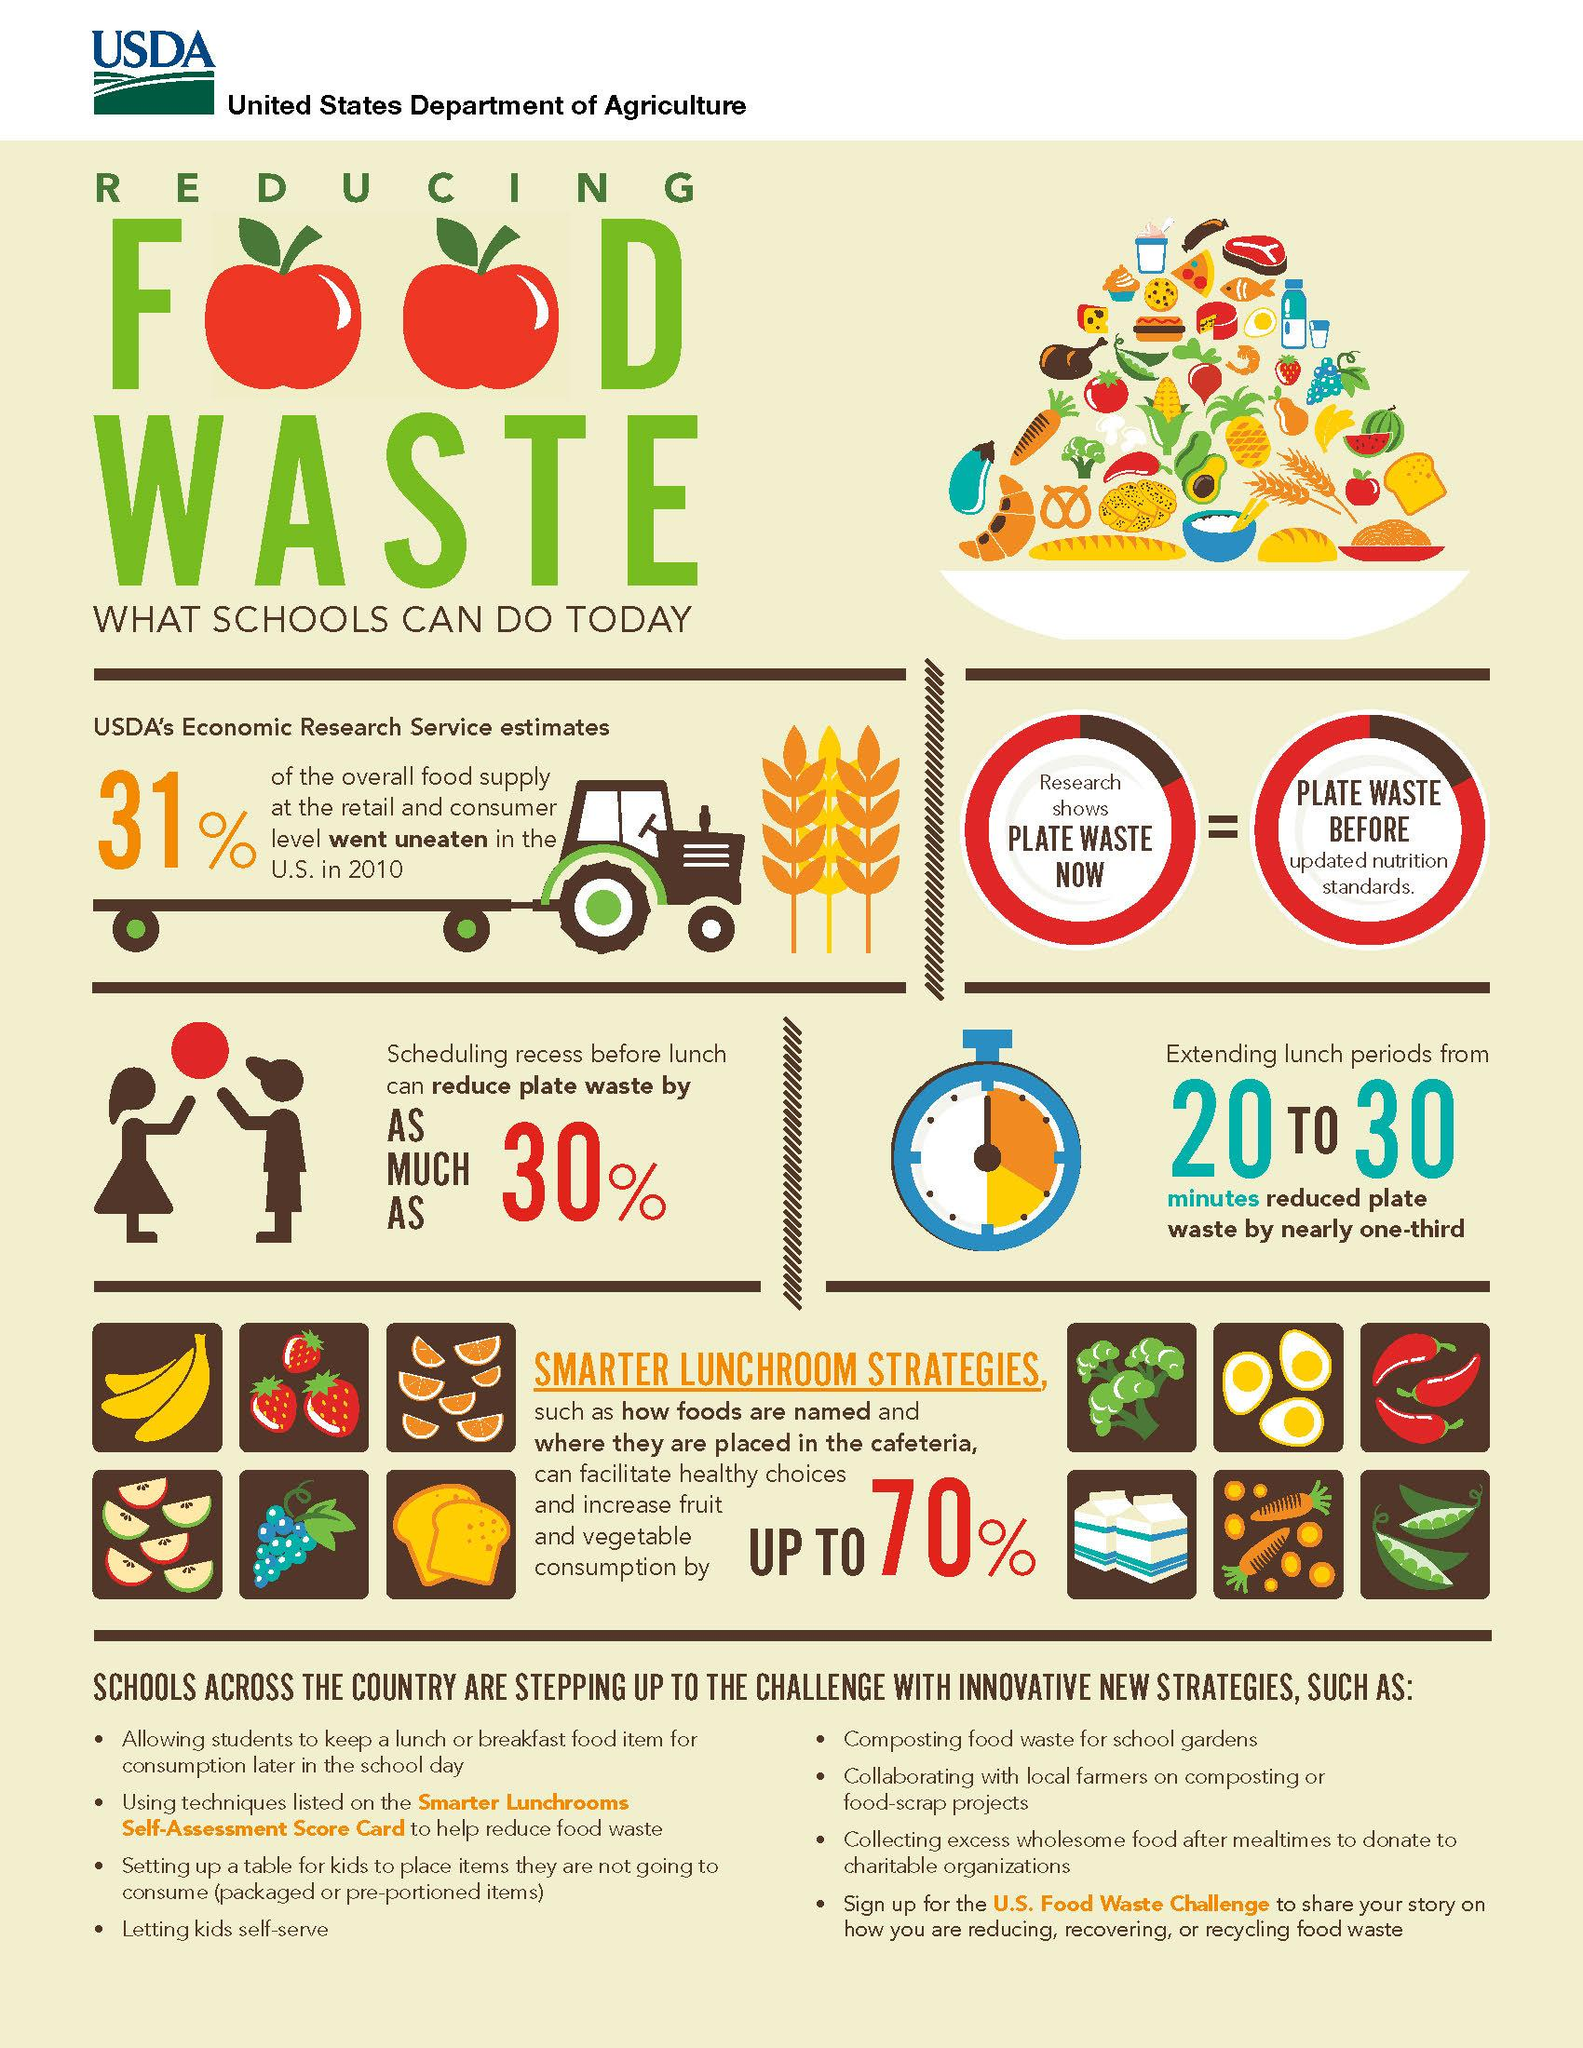Mention a couple of crucial points in this snapshot. In 2010, approximately 31% of the overall food supply at the retail and consumer level in the United States went uneaten. 